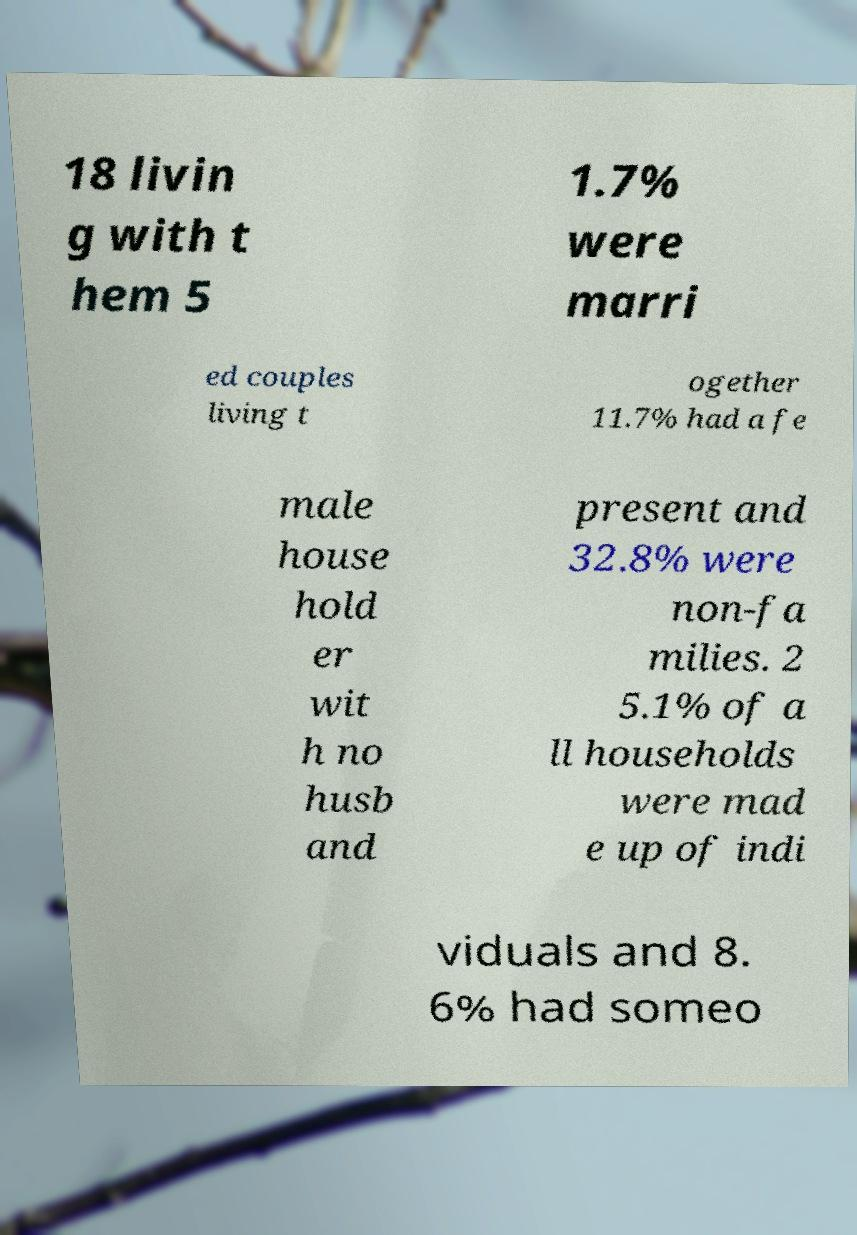I need the written content from this picture converted into text. Can you do that? 18 livin g with t hem 5 1.7% were marri ed couples living t ogether 11.7% had a fe male house hold er wit h no husb and present and 32.8% were non-fa milies. 2 5.1% of a ll households were mad e up of indi viduals and 8. 6% had someo 